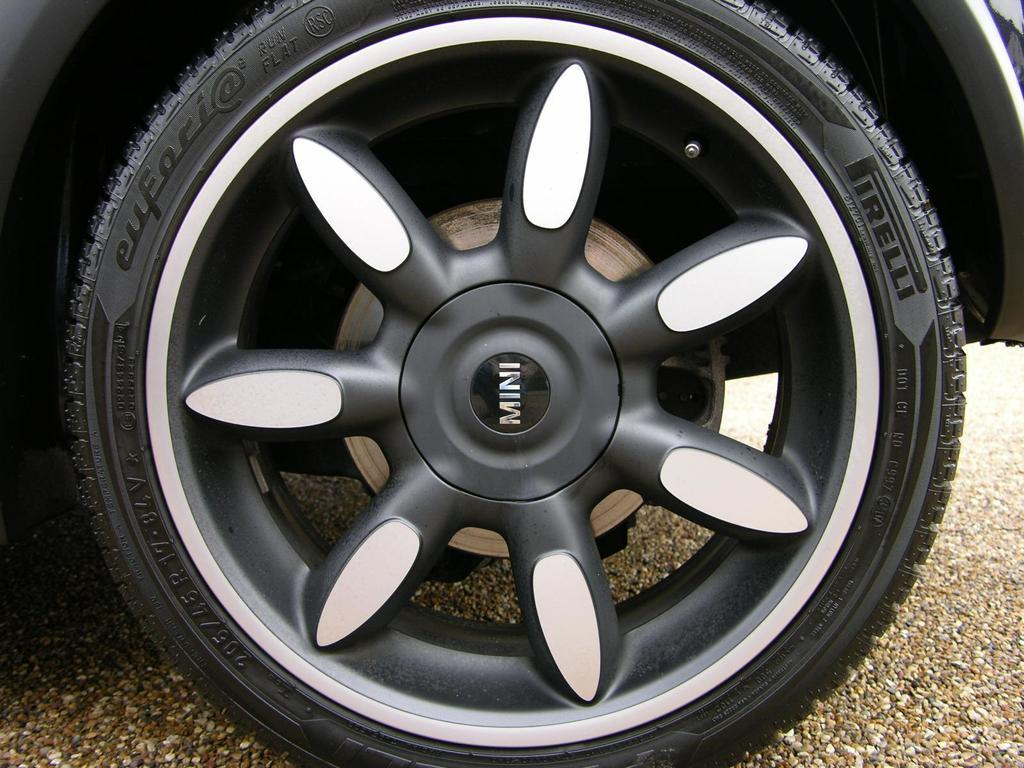What object is the main focus of the image? The main focus of the image is a wheel of a vehicle. What color scheme is used for the wheel? The wheel is black and white in color. What type of surface can be seen beneath the wheel? The ground is visible in the image. What is the color of the ground in the image? The ground is brown in color. Can you tell me how many lawyers are present in the image? There are no lawyers present in the image; it features a wheel of a vehicle and the ground. What type of agricultural tool is being used in the image? There is no agricultural tool, such as a plough, present in the image. 